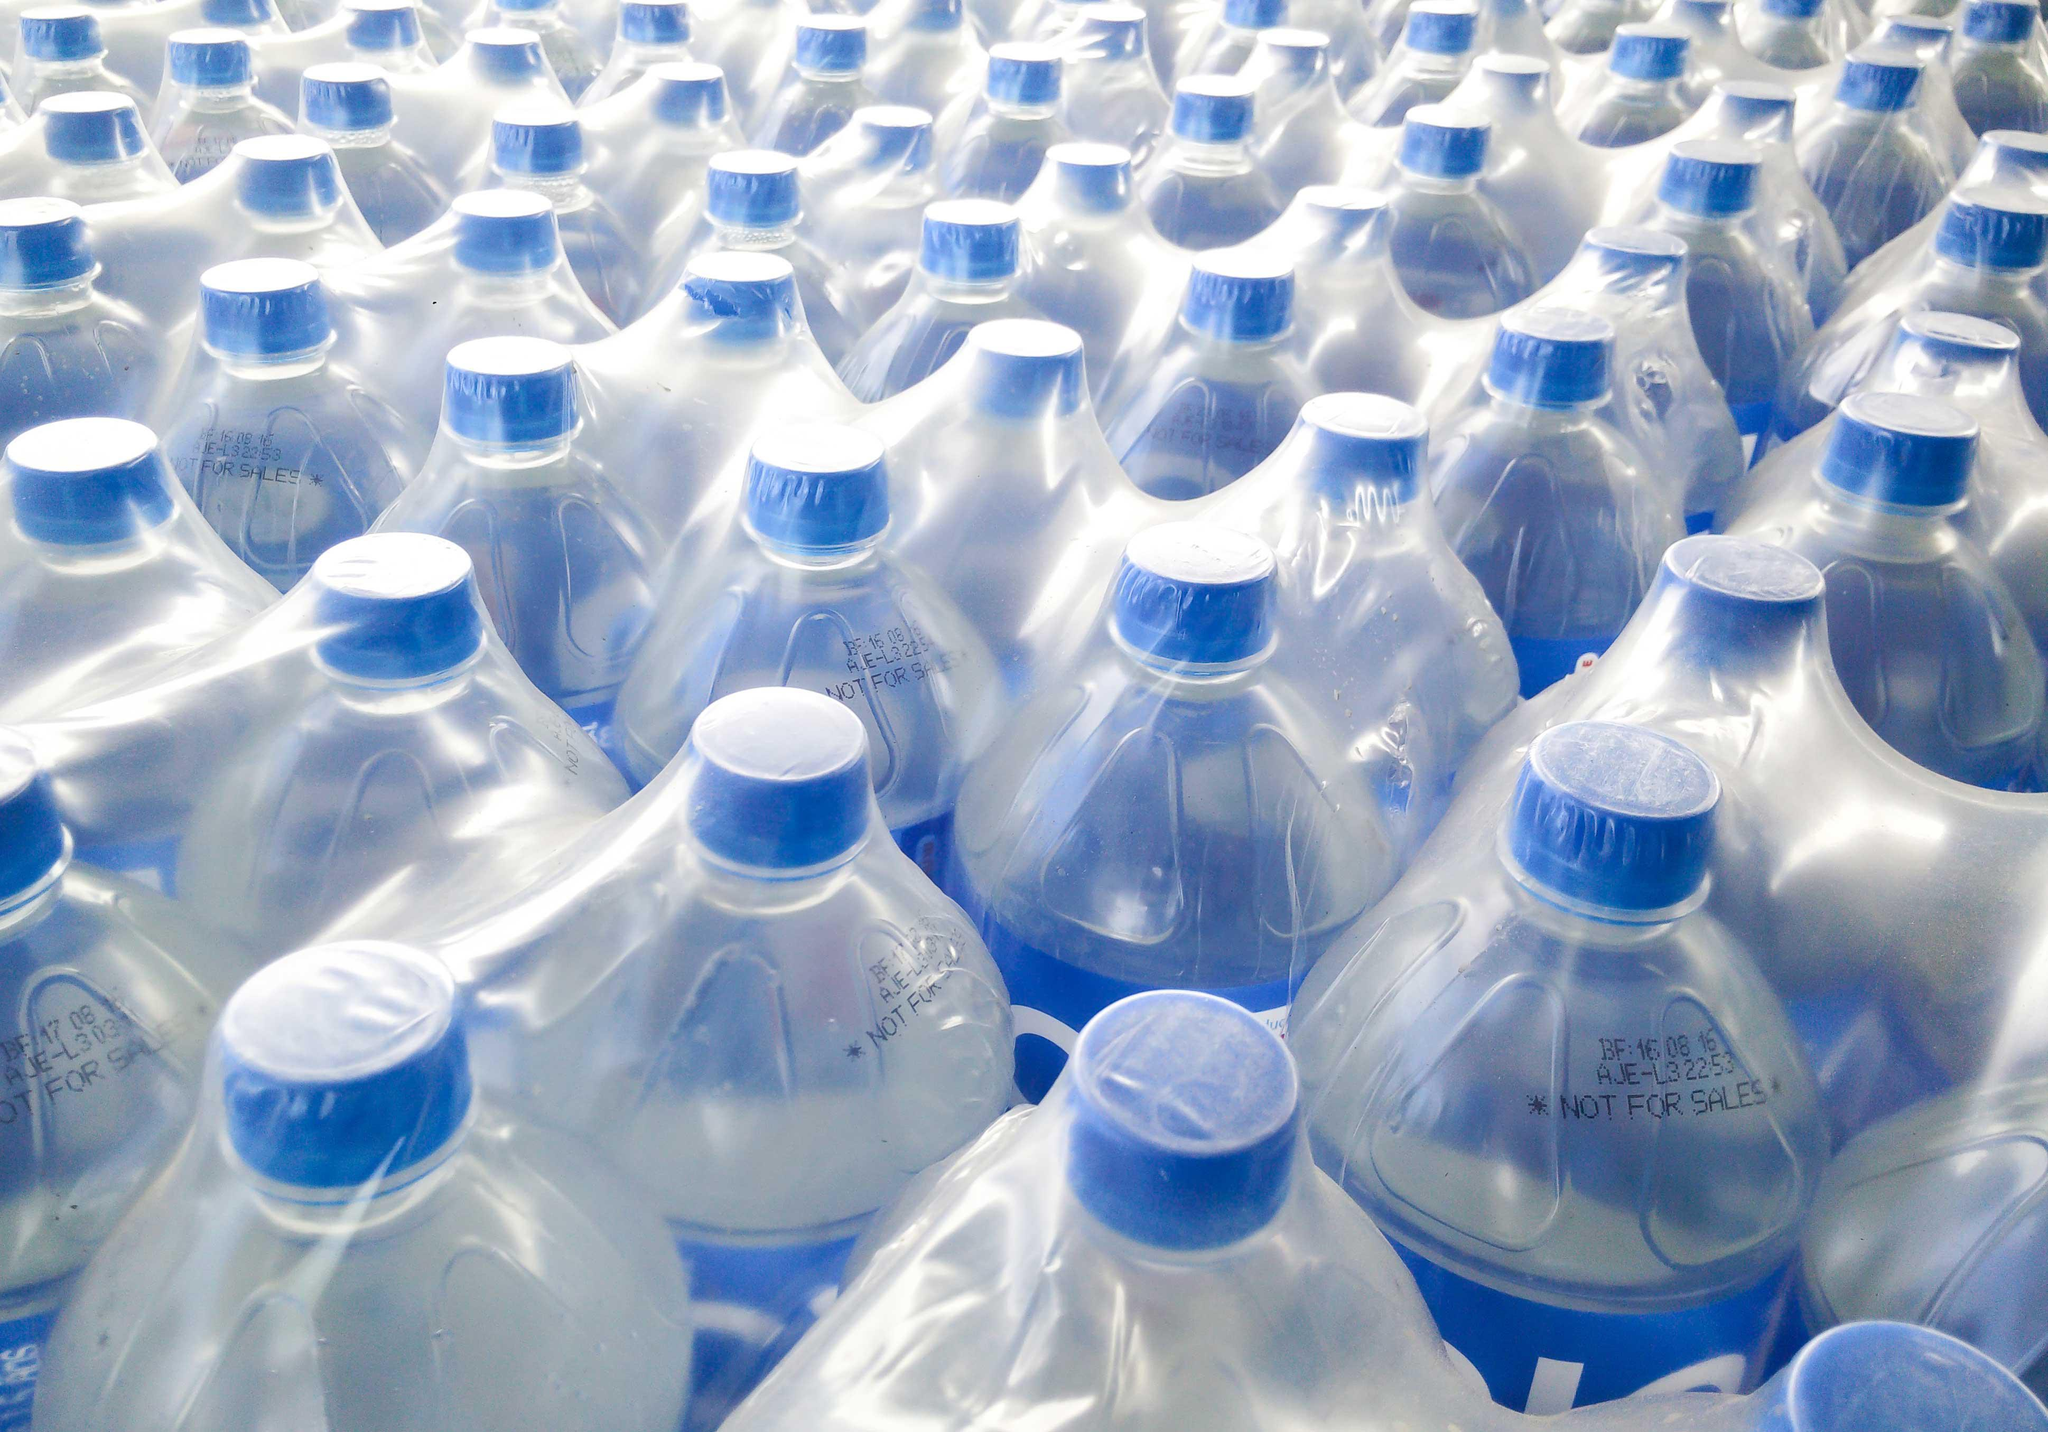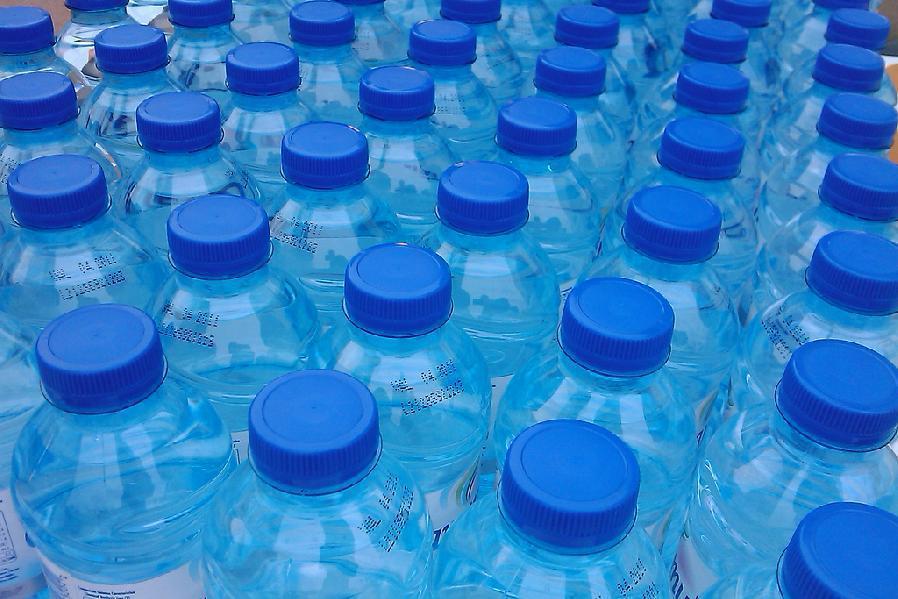The first image is the image on the left, the second image is the image on the right. Considering the images on both sides, is "The bottles in one of the images are for water coolers" valid? Answer yes or no. No. 